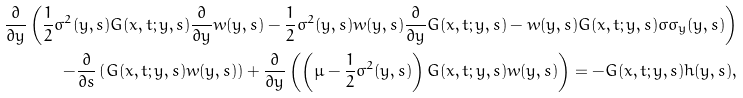Convert formula to latex. <formula><loc_0><loc_0><loc_500><loc_500>\frac { \partial } { \partial y } \left ( \frac { 1 } { 2 } \sigma ^ { 2 } ( y , s ) G ( x , t ; y , s ) \frac { \partial } { \partial y } w ( y , s ) - \frac { 1 } { 2 } \sigma ^ { 2 } ( y , s ) w ( y , s ) \frac { \partial } { \partial y } G ( x , t ; y , s ) - w ( y , s ) G ( x , t ; y , s ) \sigma \sigma _ { y } ( y , s ) \right ) \\ - \frac { \partial } { \partial s } \left ( G ( x , t ; y , s ) w ( y , s ) \right ) + \frac { \partial } { \partial y } \left ( \left ( \mu - \frac { 1 } { 2 } \sigma ^ { 2 } ( y , s ) \right ) G ( x , t ; y , s ) w ( y , s ) \right ) = - G ( x , t ; y , s ) h ( y , s ) ,</formula> 